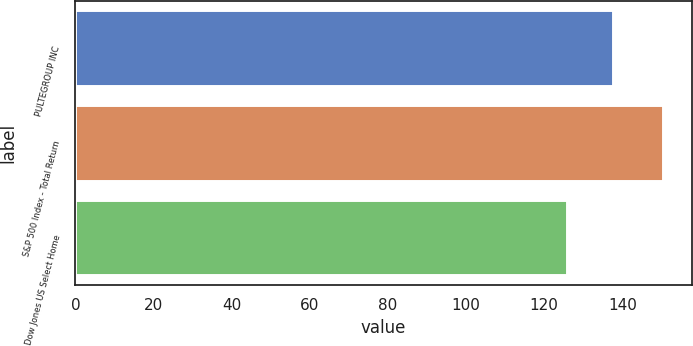<chart> <loc_0><loc_0><loc_500><loc_500><bar_chart><fcel>PULTEGROUP INC<fcel>S&P 500 Index - Total Return<fcel>Dow Jones US Select Home<nl><fcel>137.52<fcel>150.33<fcel>125.74<nl></chart> 